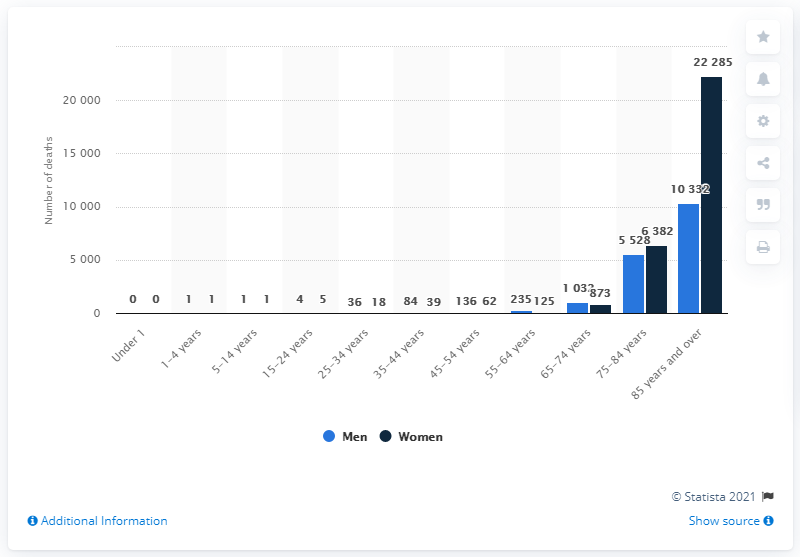Draw attention to some important aspects in this diagram. In 2019, a total of 22,285 women in England and Wales died as a result of mental and behavioral disorders. 